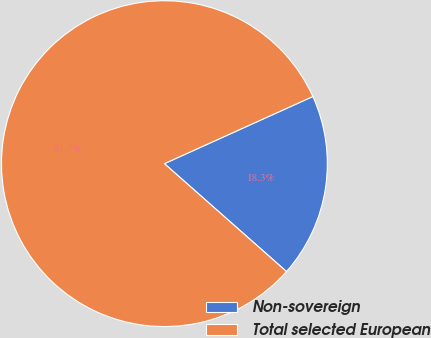Convert chart to OTSL. <chart><loc_0><loc_0><loc_500><loc_500><pie_chart><fcel>Non-sovereign<fcel>Total selected European<nl><fcel>18.28%<fcel>81.72%<nl></chart> 